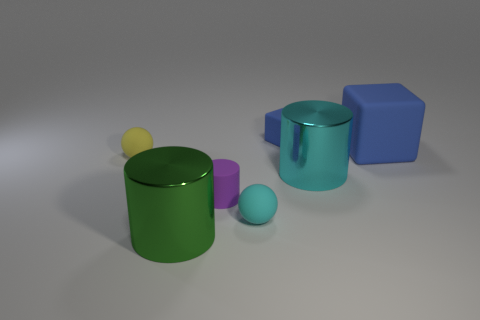Can you tell me which objects have cylindrical shapes and their respective colors? Certainly! Within the image, there are two objects with cylindrical shapes. One is a green cylinder, and the other is a translucent cyan cylinder. 